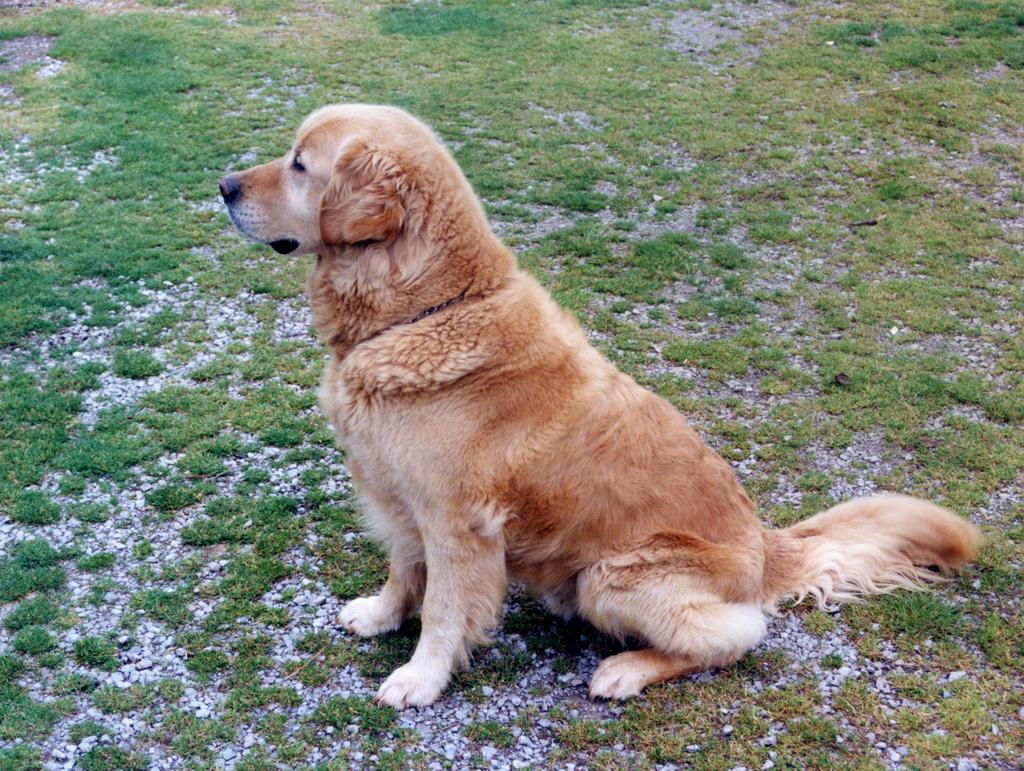What is the main subject of the image? The main subject of the image is a dog. Where is the dog located in the image? The dog is in the middle of the image. What is the color of the dog in the image? The dog is brown in color. Can you tell me how many donkeys are visible in the image? There are no donkeys present in the image, and therefore no such animals can be observed. What type of moon can be seen in the image? There is no moon present in the image; it features a dog. 